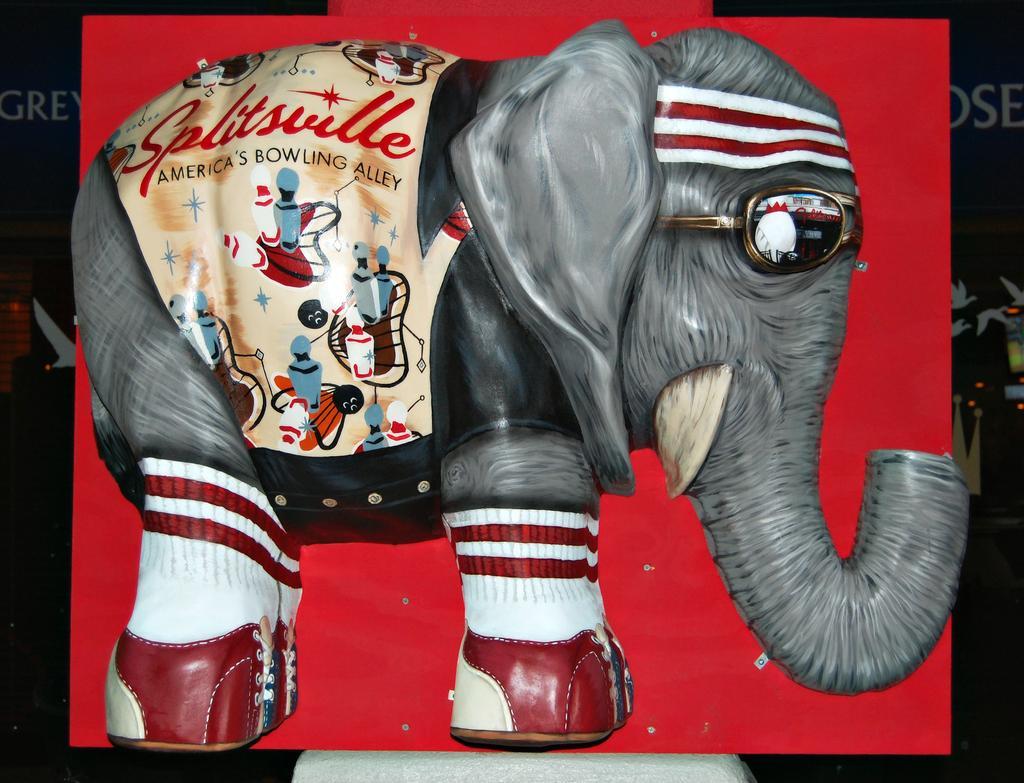Can you describe this image briefly? In this image, we can see a board contains depiction of an elephant. 